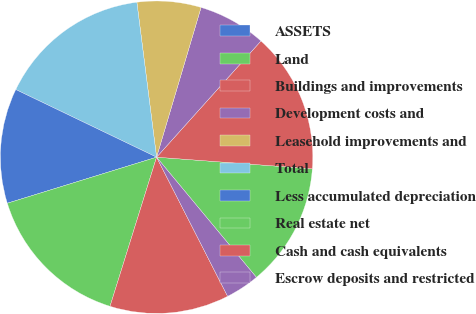<chart> <loc_0><loc_0><loc_500><loc_500><pie_chart><fcel>ASSETS<fcel>Land<fcel>Buildings and improvements<fcel>Development costs and<fcel>Leasehold improvements and<fcel>Total<fcel>Less accumulated depreciation<fcel>Real estate net<fcel>Cash and cash equivalents<fcel>Escrow deposits and restricted<nl><fcel>0.0%<fcel>12.78%<fcel>14.54%<fcel>7.05%<fcel>6.61%<fcel>15.86%<fcel>11.89%<fcel>15.42%<fcel>12.33%<fcel>3.52%<nl></chart> 